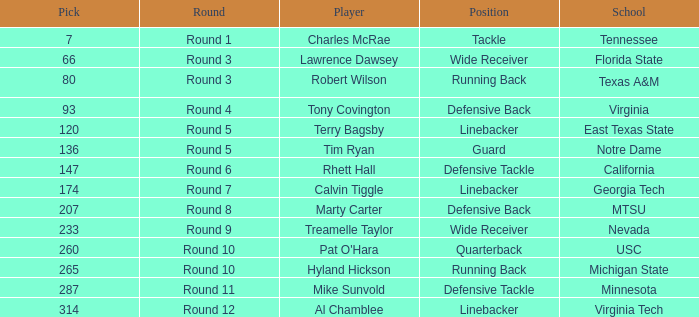What position did the player from East Texas State play? Linebacker. 